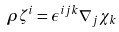Convert formula to latex. <formula><loc_0><loc_0><loc_500><loc_500>\rho \zeta ^ { i } = \epsilon ^ { i j k } \nabla _ { j } \chi _ { k }</formula> 